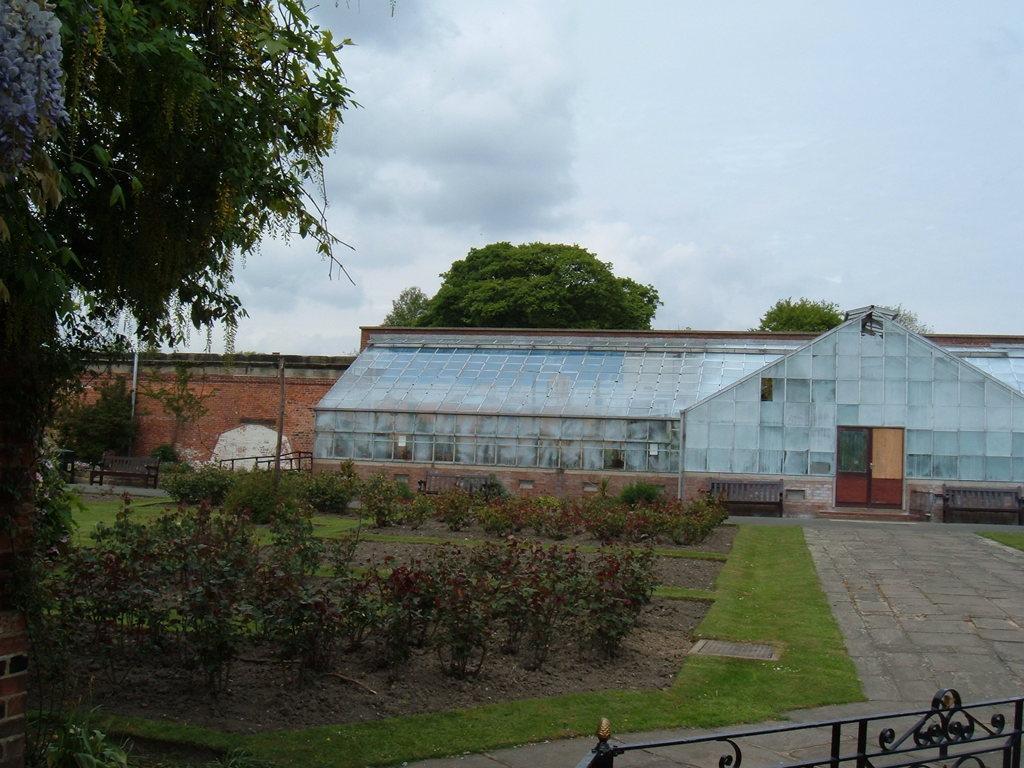In one or two sentences, can you explain what this image depicts? In the center of the image there is a building. On the left side of the image we can see tree, wall, plants and grass. At the bottom of the image we can see fencing and grass. In the background we can see trees, sky and clouds. 